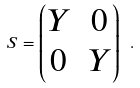<formula> <loc_0><loc_0><loc_500><loc_500>S = \begin{pmatrix} Y & 0 \\ 0 & Y \end{pmatrix} \ .</formula> 